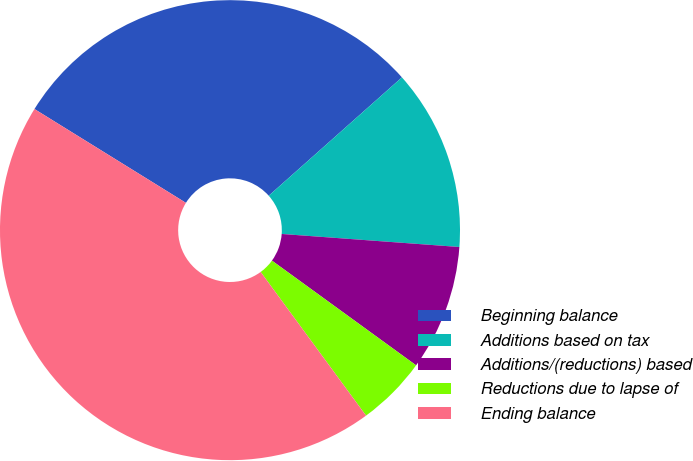Convert chart to OTSL. <chart><loc_0><loc_0><loc_500><loc_500><pie_chart><fcel>Beginning balance<fcel>Additions based on tax<fcel>Additions/(reductions) based<fcel>Reductions due to lapse of<fcel>Ending balance<nl><fcel>29.61%<fcel>12.73%<fcel>8.83%<fcel>4.93%<fcel>43.9%<nl></chart> 